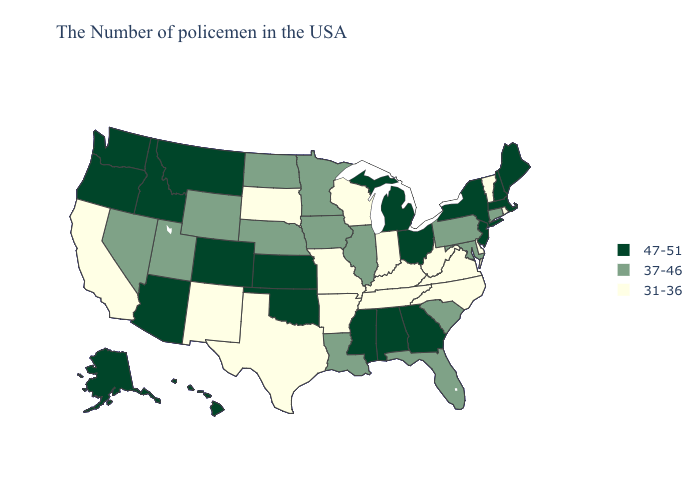What is the lowest value in the USA?
Be succinct. 31-36. Does the first symbol in the legend represent the smallest category?
Write a very short answer. No. What is the value of Mississippi?
Be succinct. 47-51. Does Delaware have the lowest value in the USA?
Quick response, please. Yes. What is the value of Maryland?
Quick response, please. 37-46. What is the value of Tennessee?
Concise answer only. 31-36. What is the value of Ohio?
Be succinct. 47-51. Does the map have missing data?
Answer briefly. No. Name the states that have a value in the range 31-36?
Concise answer only. Rhode Island, Vermont, Delaware, Virginia, North Carolina, West Virginia, Kentucky, Indiana, Tennessee, Wisconsin, Missouri, Arkansas, Texas, South Dakota, New Mexico, California. What is the value of Massachusetts?
Concise answer only. 47-51. Does Wisconsin have the lowest value in the MidWest?
Be succinct. Yes. What is the value of Maine?
Answer briefly. 47-51. What is the value of Vermont?
Quick response, please. 31-36. Which states hav the highest value in the South?
Quick response, please. Georgia, Alabama, Mississippi, Oklahoma. 